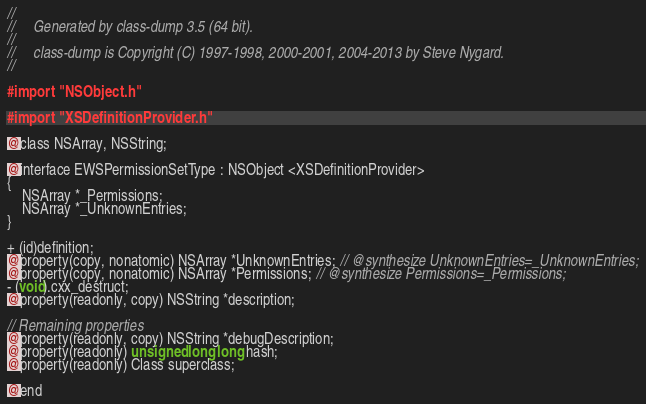Convert code to text. <code><loc_0><loc_0><loc_500><loc_500><_C_>//
//     Generated by class-dump 3.5 (64 bit).
//
//     class-dump is Copyright (C) 1997-1998, 2000-2001, 2004-2013 by Steve Nygard.
//

#import "NSObject.h"

#import "XSDefinitionProvider.h"

@class NSArray, NSString;

@interface EWSPermissionSetType : NSObject <XSDefinitionProvider>
{
    NSArray *_Permissions;
    NSArray *_UnknownEntries;
}

+ (id)definition;
@property(copy, nonatomic) NSArray *UnknownEntries; // @synthesize UnknownEntries=_UnknownEntries;
@property(copy, nonatomic) NSArray *Permissions; // @synthesize Permissions=_Permissions;
- (void).cxx_destruct;
@property(readonly, copy) NSString *description;

// Remaining properties
@property(readonly, copy) NSString *debugDescription;
@property(readonly) unsigned long long hash;
@property(readonly) Class superclass;

@end

</code> 